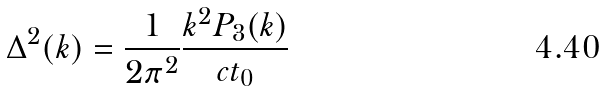<formula> <loc_0><loc_0><loc_500><loc_500>\Delta ^ { 2 } ( k ) = \frac { 1 } { 2 \pi ^ { 2 } } \frac { k ^ { 2 } P _ { 3 } ( k ) } { c t _ { 0 } }</formula> 